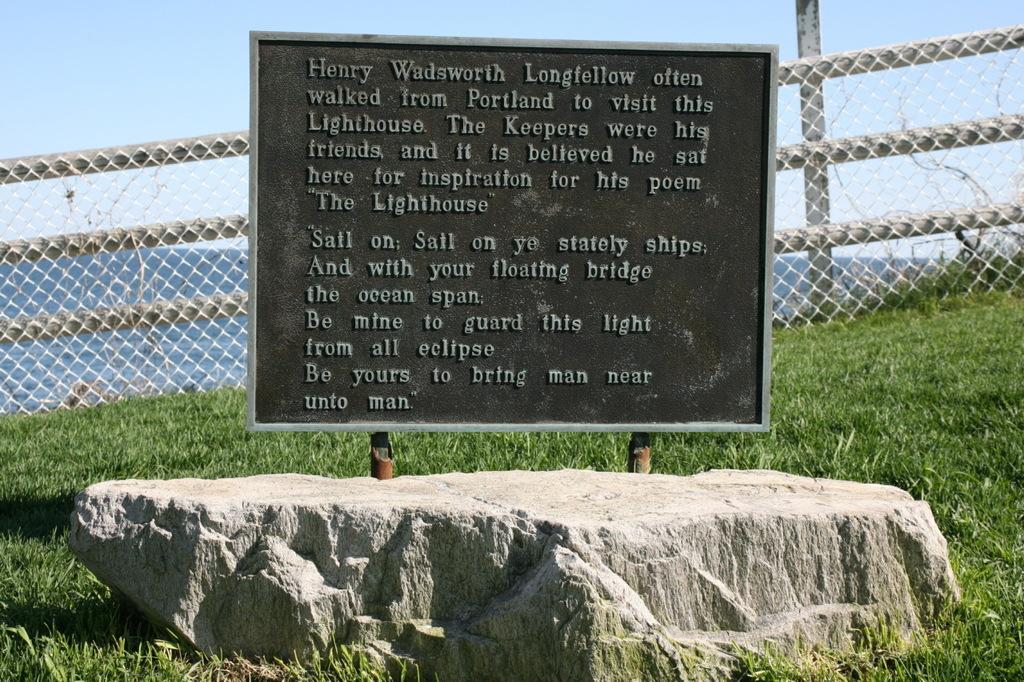What is on the board that is visible in the image? There is text on the board in the image. What is the board placed on? The board is on a stone. What can be seen in the background of the image? There is fencing, grass, mountains, and a clear sky visible in the background of the image. What type of leather is being used to make the giants' clothing in the image? There are no giants or leather clothing present in the image. 